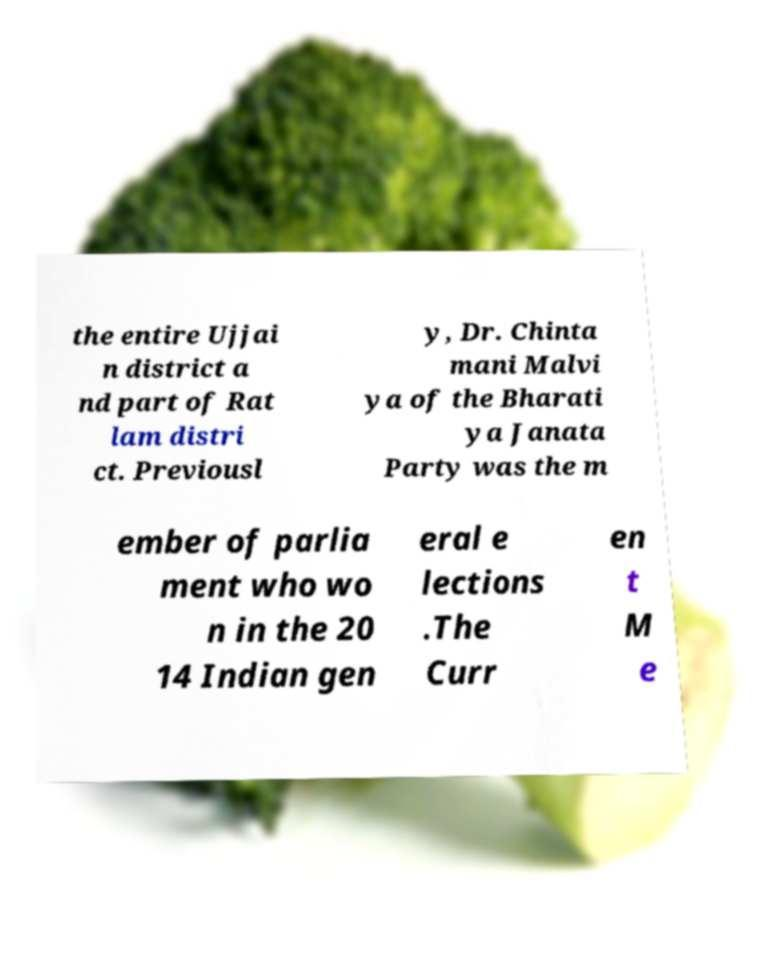What messages or text are displayed in this image? I need them in a readable, typed format. the entire Ujjai n district a nd part of Rat lam distri ct. Previousl y, Dr. Chinta mani Malvi ya of the Bharati ya Janata Party was the m ember of parlia ment who wo n in the 20 14 Indian gen eral e lections .The Curr en t M e 